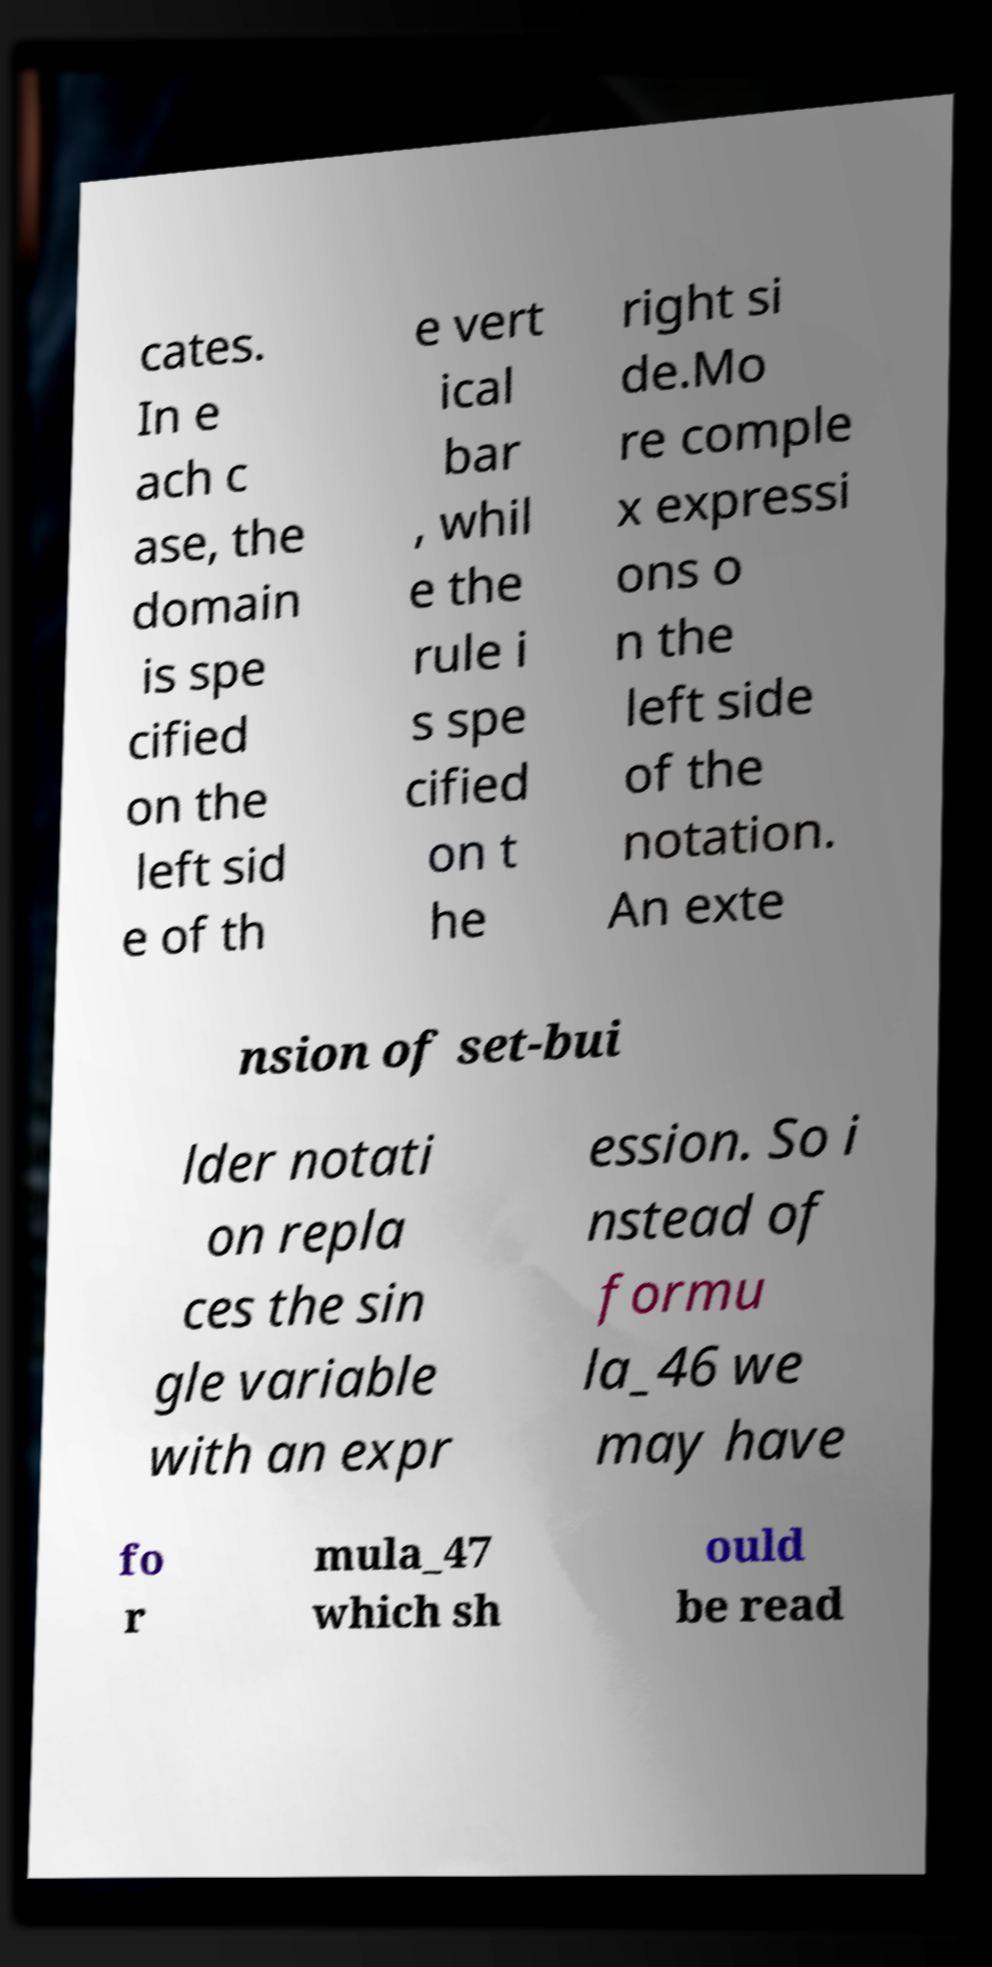I need the written content from this picture converted into text. Can you do that? cates. In e ach c ase, the domain is spe cified on the left sid e of th e vert ical bar , whil e the rule i s spe cified on t he right si de.Mo re comple x expressi ons o n the left side of the notation. An exte nsion of set-bui lder notati on repla ces the sin gle variable with an expr ession. So i nstead of formu la_46 we may have fo r mula_47 which sh ould be read 